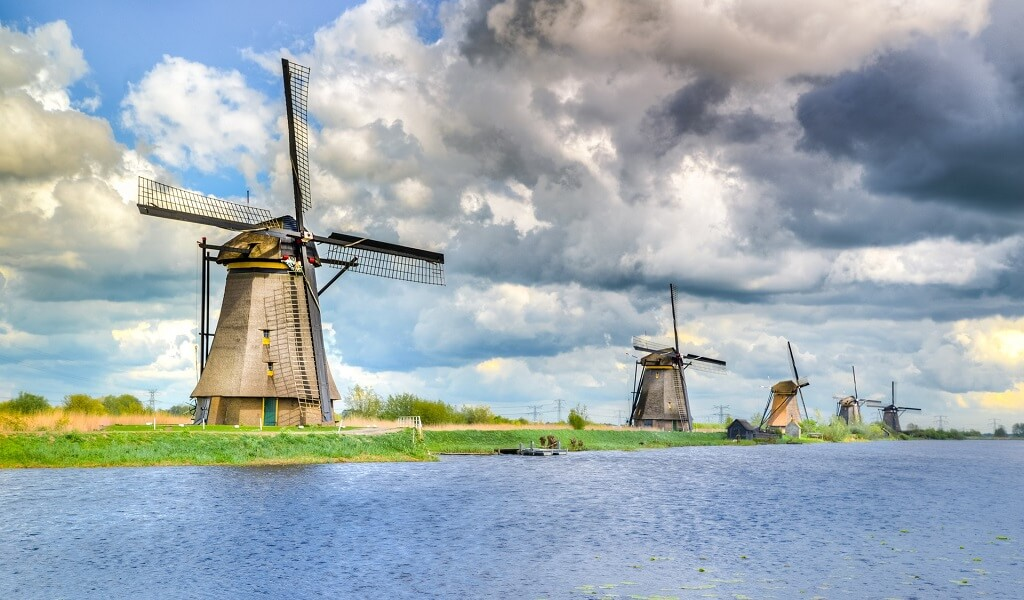What is the historical importance of these kind of windmills in the Netherlands? These windmills at Kinderdijk are a testament to the ingenuity of 18th-century Dutch water management systems. Historically, they played a crucial role in draining the swampy lands of the Alblasserwaard region, preventing floods. This network of windmills, dykes, and sluices form one of the earliest large-scale water management systems designed to maintain dry land in an area prone to flooding, underscoring the Netherlands' centuries-long fight against encroaching waters. 